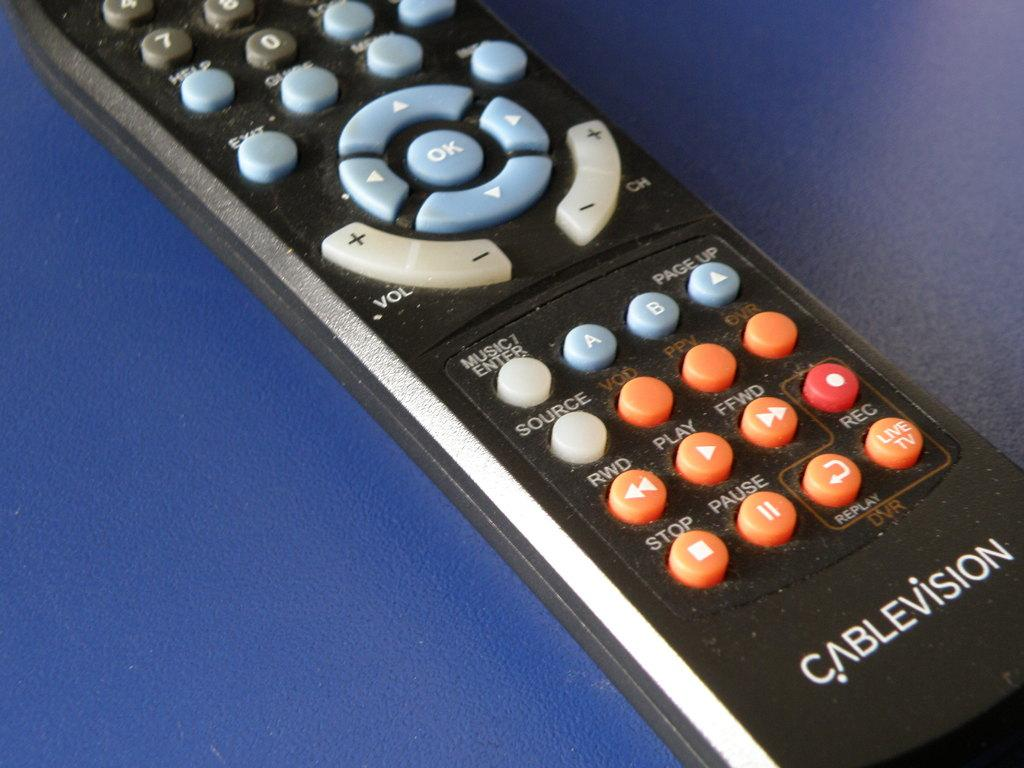<image>
Summarize the visual content of the image. Cablevision remote that is laying flat and is black with different colors 